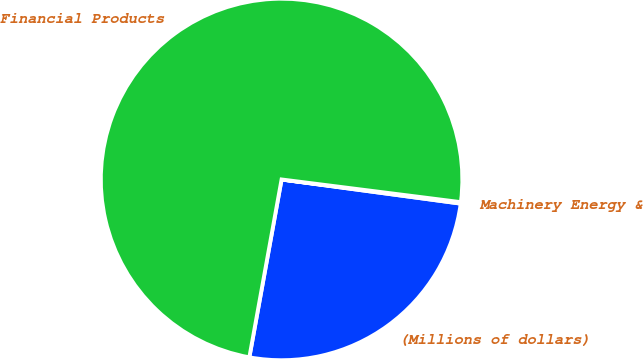Convert chart to OTSL. <chart><loc_0><loc_0><loc_500><loc_500><pie_chart><fcel>(Millions of dollars)<fcel>Machinery Energy &<fcel>Financial Products<nl><fcel>25.72%<fcel>0.13%<fcel>74.15%<nl></chart> 